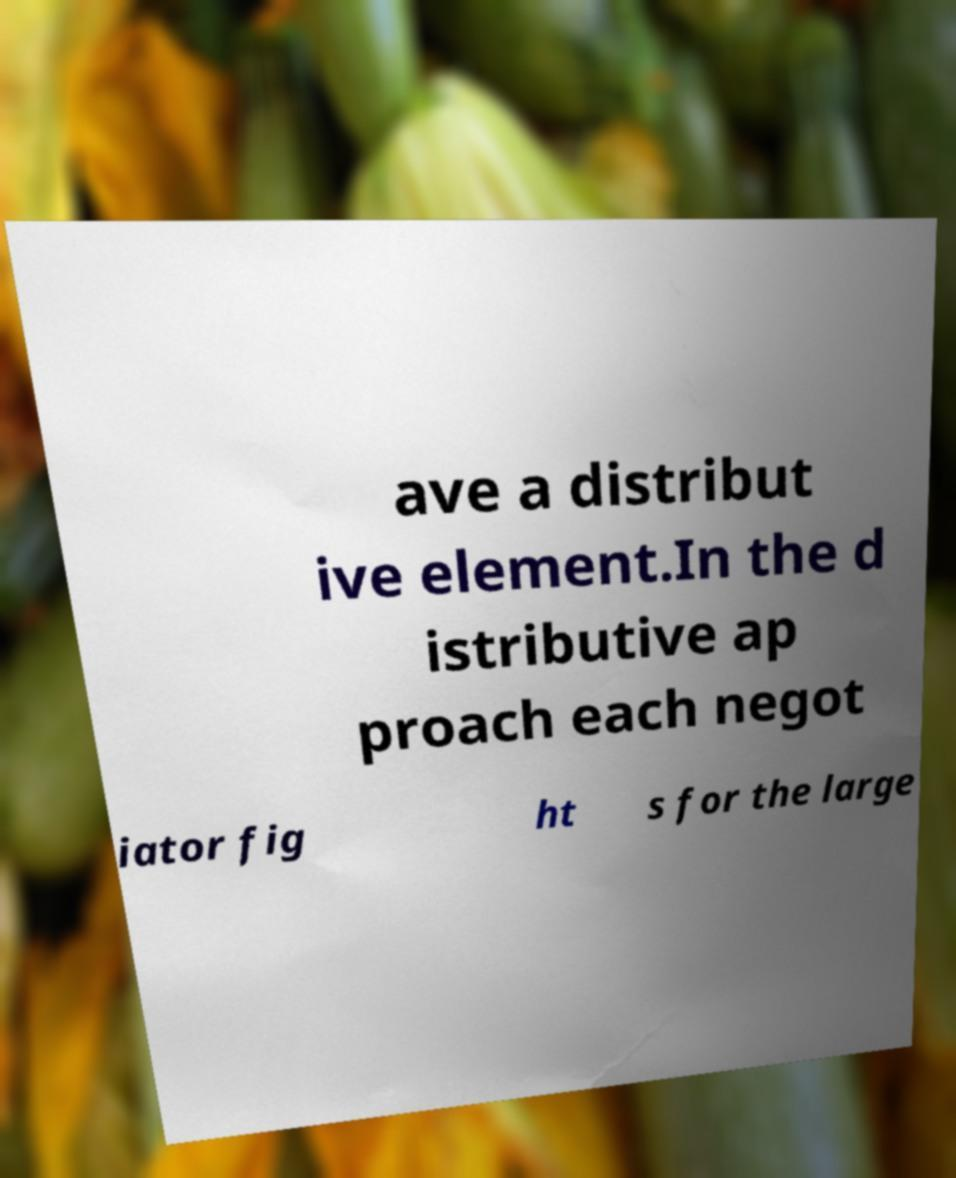What messages or text are displayed in this image? I need them in a readable, typed format. ave a distribut ive element.In the d istributive ap proach each negot iator fig ht s for the large 